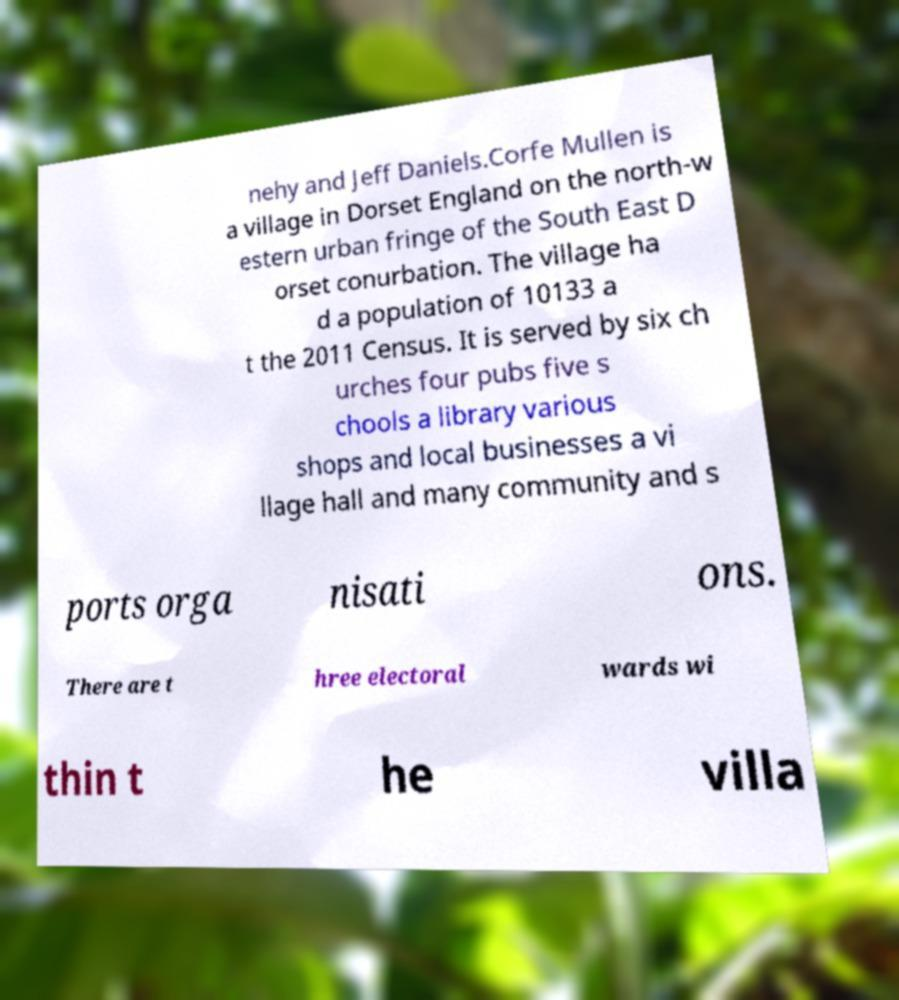Please identify and transcribe the text found in this image. nehy and Jeff Daniels.Corfe Mullen is a village in Dorset England on the north-w estern urban fringe of the South East D orset conurbation. The village ha d a population of 10133 a t the 2011 Census. It is served by six ch urches four pubs five s chools a library various shops and local businesses a vi llage hall and many community and s ports orga nisati ons. There are t hree electoral wards wi thin t he villa 